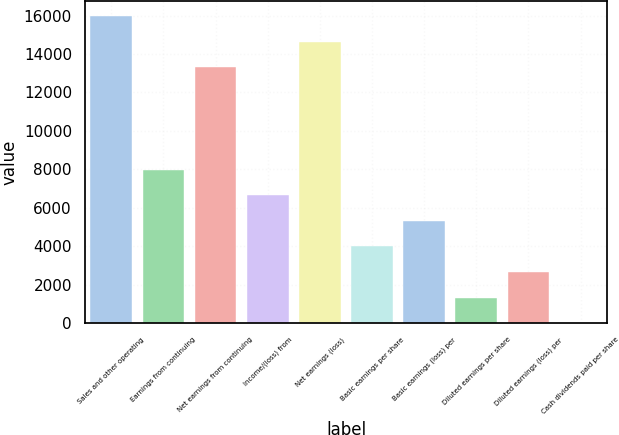Convert chart to OTSL. <chart><loc_0><loc_0><loc_500><loc_500><bar_chart><fcel>Sales and other operating<fcel>Earnings from continuing<fcel>Net earnings from continuing<fcel>Income/(loss) from<fcel>Net earnings (loss)<fcel>Basic earnings per share<fcel>Basic earnings (loss) per<fcel>Diluted earnings per share<fcel>Diluted earnings (loss) per<fcel>Cash dividends paid per share<nl><fcel>15976.8<fcel>7988.48<fcel>13314<fcel>6657.1<fcel>14645.4<fcel>3994.34<fcel>5325.72<fcel>1331.58<fcel>2662.96<fcel>0.2<nl></chart> 